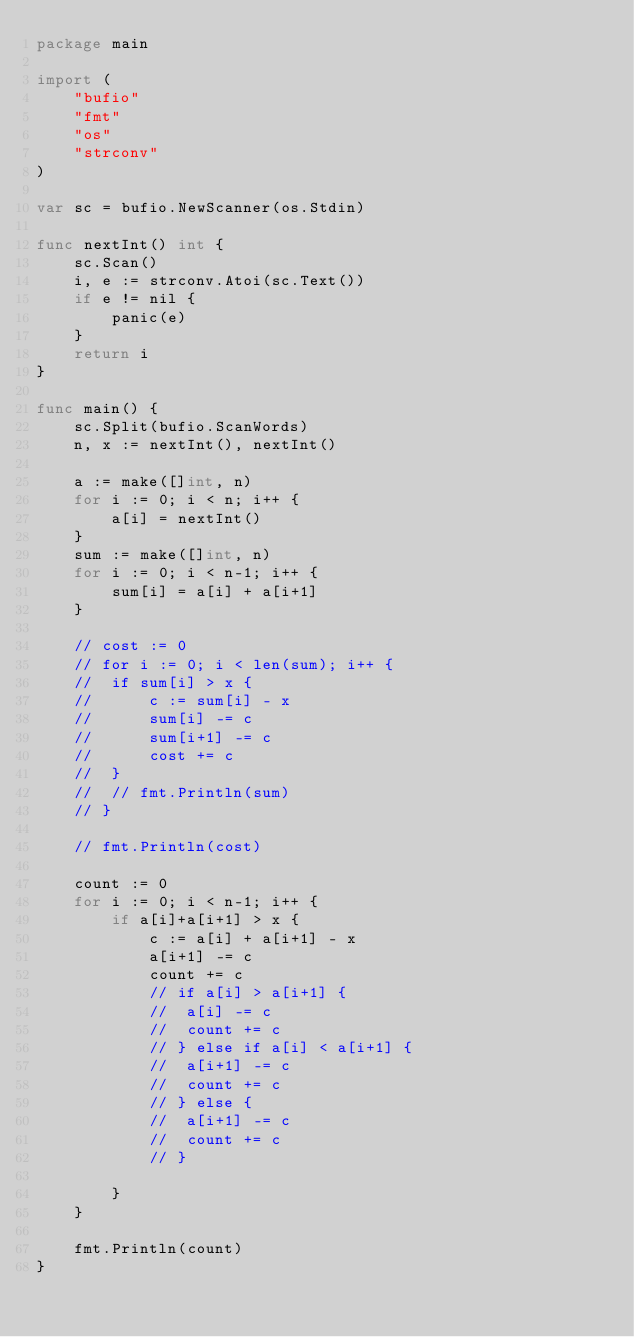<code> <loc_0><loc_0><loc_500><loc_500><_Go_>package main

import (
	"bufio"
	"fmt"
	"os"
	"strconv"
)

var sc = bufio.NewScanner(os.Stdin)

func nextInt() int {
	sc.Scan()
	i, e := strconv.Atoi(sc.Text())
	if e != nil {
		panic(e)
	}
	return i
}

func main() {
	sc.Split(bufio.ScanWords)
	n, x := nextInt(), nextInt()

	a := make([]int, n)
	for i := 0; i < n; i++ {
		a[i] = nextInt()
	}
	sum := make([]int, n)
	for i := 0; i < n-1; i++ {
		sum[i] = a[i] + a[i+1]
	}

	// cost := 0
	// for i := 0; i < len(sum); i++ {
	// 	if sum[i] > x {
	// 		c := sum[i] - x
	// 		sum[i] -= c
	// 		sum[i+1] -= c
	// 		cost += c
	// 	}
	// 	// fmt.Println(sum)
	// }

	// fmt.Println(cost)

	count := 0
	for i := 0; i < n-1; i++ {
		if a[i]+a[i+1] > x {
			c := a[i] + a[i+1] - x
			a[i+1] -= c
			count += c
			// if a[i] > a[i+1] {
			// 	a[i] -= c
			// 	count += c
			// } else if a[i] < a[i+1] {
			// 	a[i+1] -= c
			// 	count += c
			// } else {
			// 	a[i+1] -= c
			// 	count += c
			// }

		}
	}

	fmt.Println(count)
}
</code> 